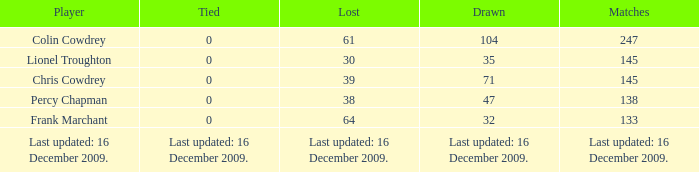Name the tie that has 71 drawn 0.0. 